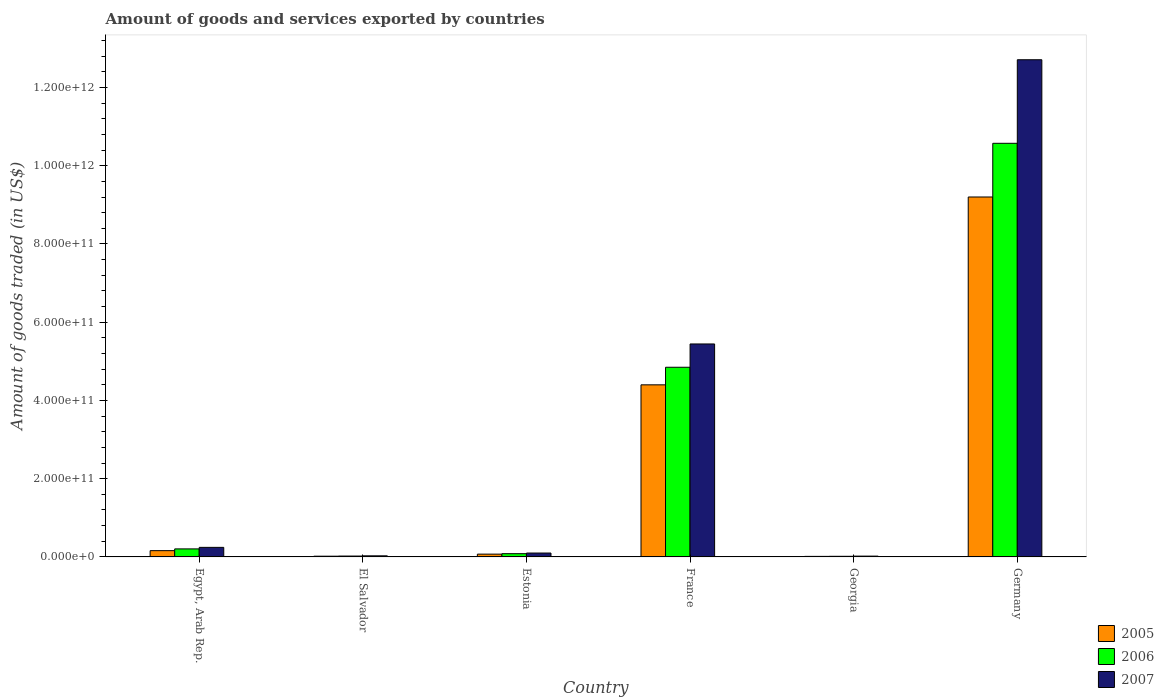How many groups of bars are there?
Your response must be concise. 6. Are the number of bars per tick equal to the number of legend labels?
Your response must be concise. Yes. How many bars are there on the 1st tick from the left?
Ensure brevity in your answer.  3. How many bars are there on the 2nd tick from the right?
Keep it short and to the point. 3. What is the label of the 2nd group of bars from the left?
Keep it short and to the point. El Salvador. What is the total amount of goods and services exported in 2005 in Georgia?
Your answer should be compact. 1.41e+09. Across all countries, what is the maximum total amount of goods and services exported in 2006?
Offer a terse response. 1.06e+12. Across all countries, what is the minimum total amount of goods and services exported in 2007?
Provide a short and direct response. 2.06e+09. In which country was the total amount of goods and services exported in 2005 minimum?
Keep it short and to the point. Georgia. What is the total total amount of goods and services exported in 2006 in the graph?
Offer a very short reply. 1.57e+12. What is the difference between the total amount of goods and services exported in 2005 in France and that in Germany?
Offer a very short reply. -4.80e+11. What is the difference between the total amount of goods and services exported in 2007 in France and the total amount of goods and services exported in 2006 in El Salvador?
Offer a very short reply. 5.42e+11. What is the average total amount of goods and services exported in 2006 per country?
Ensure brevity in your answer.  2.62e+11. What is the difference between the total amount of goods and services exported of/in 2006 and total amount of goods and services exported of/in 2007 in Georgia?
Ensure brevity in your answer.  -4.69e+08. In how many countries, is the total amount of goods and services exported in 2006 greater than 1200000000000 US$?
Your answer should be very brief. 0. What is the ratio of the total amount of goods and services exported in 2005 in El Salvador to that in Germany?
Your answer should be very brief. 0. What is the difference between the highest and the second highest total amount of goods and services exported in 2006?
Your response must be concise. 1.04e+12. What is the difference between the highest and the lowest total amount of goods and services exported in 2007?
Offer a very short reply. 1.27e+12. Is the sum of the total amount of goods and services exported in 2007 in El Salvador and Estonia greater than the maximum total amount of goods and services exported in 2005 across all countries?
Offer a very short reply. No. What does the 2nd bar from the right in Germany represents?
Give a very brief answer. 2006. Is it the case that in every country, the sum of the total amount of goods and services exported in 2007 and total amount of goods and services exported in 2005 is greater than the total amount of goods and services exported in 2006?
Your response must be concise. Yes. How many bars are there?
Ensure brevity in your answer.  18. Are all the bars in the graph horizontal?
Provide a short and direct response. No. What is the difference between two consecutive major ticks on the Y-axis?
Offer a very short reply. 2.00e+11. Does the graph contain grids?
Provide a succinct answer. No. What is the title of the graph?
Your answer should be very brief. Amount of goods and services exported by countries. Does "1989" appear as one of the legend labels in the graph?
Provide a succinct answer. No. What is the label or title of the X-axis?
Ensure brevity in your answer.  Country. What is the label or title of the Y-axis?
Keep it short and to the point. Amount of goods traded (in US$). What is the Amount of goods traded (in US$) of 2005 in Egypt, Arab Rep.?
Keep it short and to the point. 1.61e+1. What is the Amount of goods traded (in US$) in 2006 in Egypt, Arab Rep.?
Offer a very short reply. 2.05e+1. What is the Amount of goods traded (in US$) in 2007 in Egypt, Arab Rep.?
Make the answer very short. 2.45e+1. What is the Amount of goods traded (in US$) of 2005 in El Salvador?
Your answer should be very brief. 1.86e+09. What is the Amount of goods traded (in US$) in 2006 in El Salvador?
Your answer should be compact. 2.25e+09. What is the Amount of goods traded (in US$) in 2007 in El Salvador?
Offer a terse response. 2.79e+09. What is the Amount of goods traded (in US$) of 2005 in Estonia?
Offer a very short reply. 7.16e+09. What is the Amount of goods traded (in US$) of 2006 in Estonia?
Make the answer very short. 8.31e+09. What is the Amount of goods traded (in US$) in 2007 in Estonia?
Offer a terse response. 9.93e+09. What is the Amount of goods traded (in US$) of 2005 in France?
Provide a short and direct response. 4.40e+11. What is the Amount of goods traded (in US$) of 2006 in France?
Keep it short and to the point. 4.85e+11. What is the Amount of goods traded (in US$) of 2007 in France?
Your response must be concise. 5.44e+11. What is the Amount of goods traded (in US$) of 2005 in Georgia?
Your response must be concise. 1.41e+09. What is the Amount of goods traded (in US$) in 2006 in Georgia?
Offer a terse response. 1.59e+09. What is the Amount of goods traded (in US$) of 2007 in Georgia?
Your answer should be very brief. 2.06e+09. What is the Amount of goods traded (in US$) of 2005 in Germany?
Your answer should be very brief. 9.20e+11. What is the Amount of goods traded (in US$) of 2006 in Germany?
Provide a short and direct response. 1.06e+12. What is the Amount of goods traded (in US$) of 2007 in Germany?
Ensure brevity in your answer.  1.27e+12. Across all countries, what is the maximum Amount of goods traded (in US$) in 2005?
Offer a terse response. 9.20e+11. Across all countries, what is the maximum Amount of goods traded (in US$) of 2006?
Your answer should be very brief. 1.06e+12. Across all countries, what is the maximum Amount of goods traded (in US$) in 2007?
Provide a succinct answer. 1.27e+12. Across all countries, what is the minimum Amount of goods traded (in US$) in 2005?
Your response must be concise. 1.41e+09. Across all countries, what is the minimum Amount of goods traded (in US$) of 2006?
Offer a very short reply. 1.59e+09. Across all countries, what is the minimum Amount of goods traded (in US$) in 2007?
Your response must be concise. 2.06e+09. What is the total Amount of goods traded (in US$) in 2005 in the graph?
Your answer should be compact. 1.39e+12. What is the total Amount of goods traded (in US$) of 2006 in the graph?
Offer a terse response. 1.57e+12. What is the total Amount of goods traded (in US$) in 2007 in the graph?
Keep it short and to the point. 1.85e+12. What is the difference between the Amount of goods traded (in US$) of 2005 in Egypt, Arab Rep. and that in El Salvador?
Provide a short and direct response. 1.42e+1. What is the difference between the Amount of goods traded (in US$) in 2006 in Egypt, Arab Rep. and that in El Salvador?
Offer a terse response. 1.83e+1. What is the difference between the Amount of goods traded (in US$) of 2007 in Egypt, Arab Rep. and that in El Salvador?
Offer a terse response. 2.17e+1. What is the difference between the Amount of goods traded (in US$) of 2005 in Egypt, Arab Rep. and that in Estonia?
Give a very brief answer. 8.91e+09. What is the difference between the Amount of goods traded (in US$) of 2006 in Egypt, Arab Rep. and that in Estonia?
Give a very brief answer. 1.22e+1. What is the difference between the Amount of goods traded (in US$) of 2007 in Egypt, Arab Rep. and that in Estonia?
Your response must be concise. 1.45e+1. What is the difference between the Amount of goods traded (in US$) of 2005 in Egypt, Arab Rep. and that in France?
Your answer should be compact. -4.24e+11. What is the difference between the Amount of goods traded (in US$) in 2006 in Egypt, Arab Rep. and that in France?
Provide a short and direct response. -4.64e+11. What is the difference between the Amount of goods traded (in US$) in 2007 in Egypt, Arab Rep. and that in France?
Your answer should be compact. -5.20e+11. What is the difference between the Amount of goods traded (in US$) of 2005 in Egypt, Arab Rep. and that in Georgia?
Your answer should be very brief. 1.47e+1. What is the difference between the Amount of goods traded (in US$) of 2006 in Egypt, Arab Rep. and that in Georgia?
Your response must be concise. 1.90e+1. What is the difference between the Amount of goods traded (in US$) in 2007 in Egypt, Arab Rep. and that in Georgia?
Offer a terse response. 2.24e+1. What is the difference between the Amount of goods traded (in US$) in 2005 in Egypt, Arab Rep. and that in Germany?
Offer a terse response. -9.04e+11. What is the difference between the Amount of goods traded (in US$) in 2006 in Egypt, Arab Rep. and that in Germany?
Ensure brevity in your answer.  -1.04e+12. What is the difference between the Amount of goods traded (in US$) in 2007 in Egypt, Arab Rep. and that in Germany?
Your response must be concise. -1.25e+12. What is the difference between the Amount of goods traded (in US$) in 2005 in El Salvador and that in Estonia?
Provide a short and direct response. -5.30e+09. What is the difference between the Amount of goods traded (in US$) in 2006 in El Salvador and that in Estonia?
Provide a succinct answer. -6.05e+09. What is the difference between the Amount of goods traded (in US$) of 2007 in El Salvador and that in Estonia?
Your response must be concise. -7.13e+09. What is the difference between the Amount of goods traded (in US$) in 2005 in El Salvador and that in France?
Keep it short and to the point. -4.38e+11. What is the difference between the Amount of goods traded (in US$) in 2006 in El Salvador and that in France?
Give a very brief answer. -4.83e+11. What is the difference between the Amount of goods traded (in US$) of 2007 in El Salvador and that in France?
Offer a very short reply. -5.42e+11. What is the difference between the Amount of goods traded (in US$) of 2005 in El Salvador and that in Georgia?
Your response must be concise. 4.50e+08. What is the difference between the Amount of goods traded (in US$) in 2006 in El Salvador and that in Georgia?
Give a very brief answer. 6.68e+08. What is the difference between the Amount of goods traded (in US$) in 2007 in El Salvador and that in Georgia?
Provide a short and direct response. 7.38e+08. What is the difference between the Amount of goods traded (in US$) in 2005 in El Salvador and that in Germany?
Your answer should be compact. -9.18e+11. What is the difference between the Amount of goods traded (in US$) of 2006 in El Salvador and that in Germany?
Provide a succinct answer. -1.06e+12. What is the difference between the Amount of goods traded (in US$) of 2007 in El Salvador and that in Germany?
Make the answer very short. -1.27e+12. What is the difference between the Amount of goods traded (in US$) of 2005 in Estonia and that in France?
Your answer should be compact. -4.33e+11. What is the difference between the Amount of goods traded (in US$) of 2006 in Estonia and that in France?
Offer a very short reply. -4.77e+11. What is the difference between the Amount of goods traded (in US$) in 2007 in Estonia and that in France?
Offer a terse response. -5.34e+11. What is the difference between the Amount of goods traded (in US$) of 2005 in Estonia and that in Georgia?
Provide a succinct answer. 5.75e+09. What is the difference between the Amount of goods traded (in US$) of 2006 in Estonia and that in Georgia?
Your response must be concise. 6.72e+09. What is the difference between the Amount of goods traded (in US$) in 2007 in Estonia and that in Georgia?
Your response must be concise. 7.87e+09. What is the difference between the Amount of goods traded (in US$) in 2005 in Estonia and that in Germany?
Offer a terse response. -9.13e+11. What is the difference between the Amount of goods traded (in US$) of 2006 in Estonia and that in Germany?
Your answer should be very brief. -1.05e+12. What is the difference between the Amount of goods traded (in US$) of 2007 in Estonia and that in Germany?
Provide a succinct answer. -1.26e+12. What is the difference between the Amount of goods traded (in US$) of 2005 in France and that in Georgia?
Offer a terse response. 4.38e+11. What is the difference between the Amount of goods traded (in US$) of 2006 in France and that in Georgia?
Offer a very short reply. 4.83e+11. What is the difference between the Amount of goods traded (in US$) of 2007 in France and that in Georgia?
Offer a very short reply. 5.42e+11. What is the difference between the Amount of goods traded (in US$) of 2005 in France and that in Germany?
Your answer should be very brief. -4.80e+11. What is the difference between the Amount of goods traded (in US$) of 2006 in France and that in Germany?
Ensure brevity in your answer.  -5.72e+11. What is the difference between the Amount of goods traded (in US$) in 2007 in France and that in Germany?
Provide a succinct answer. -7.27e+11. What is the difference between the Amount of goods traded (in US$) of 2005 in Georgia and that in Germany?
Offer a very short reply. -9.19e+11. What is the difference between the Amount of goods traded (in US$) in 2006 in Georgia and that in Germany?
Make the answer very short. -1.06e+12. What is the difference between the Amount of goods traded (in US$) of 2007 in Georgia and that in Germany?
Keep it short and to the point. -1.27e+12. What is the difference between the Amount of goods traded (in US$) of 2005 in Egypt, Arab Rep. and the Amount of goods traded (in US$) of 2006 in El Salvador?
Provide a short and direct response. 1.38e+1. What is the difference between the Amount of goods traded (in US$) in 2005 in Egypt, Arab Rep. and the Amount of goods traded (in US$) in 2007 in El Salvador?
Your answer should be compact. 1.33e+1. What is the difference between the Amount of goods traded (in US$) of 2006 in Egypt, Arab Rep. and the Amount of goods traded (in US$) of 2007 in El Salvador?
Offer a very short reply. 1.78e+1. What is the difference between the Amount of goods traded (in US$) in 2005 in Egypt, Arab Rep. and the Amount of goods traded (in US$) in 2006 in Estonia?
Give a very brief answer. 7.76e+09. What is the difference between the Amount of goods traded (in US$) in 2005 in Egypt, Arab Rep. and the Amount of goods traded (in US$) in 2007 in Estonia?
Provide a short and direct response. 6.15e+09. What is the difference between the Amount of goods traded (in US$) of 2006 in Egypt, Arab Rep. and the Amount of goods traded (in US$) of 2007 in Estonia?
Your response must be concise. 1.06e+1. What is the difference between the Amount of goods traded (in US$) in 2005 in Egypt, Arab Rep. and the Amount of goods traded (in US$) in 2006 in France?
Your answer should be very brief. -4.69e+11. What is the difference between the Amount of goods traded (in US$) in 2005 in Egypt, Arab Rep. and the Amount of goods traded (in US$) in 2007 in France?
Keep it short and to the point. -5.28e+11. What is the difference between the Amount of goods traded (in US$) in 2006 in Egypt, Arab Rep. and the Amount of goods traded (in US$) in 2007 in France?
Provide a short and direct response. -5.24e+11. What is the difference between the Amount of goods traded (in US$) of 2005 in Egypt, Arab Rep. and the Amount of goods traded (in US$) of 2006 in Georgia?
Your answer should be compact. 1.45e+1. What is the difference between the Amount of goods traded (in US$) in 2005 in Egypt, Arab Rep. and the Amount of goods traded (in US$) in 2007 in Georgia?
Provide a short and direct response. 1.40e+1. What is the difference between the Amount of goods traded (in US$) of 2006 in Egypt, Arab Rep. and the Amount of goods traded (in US$) of 2007 in Georgia?
Make the answer very short. 1.85e+1. What is the difference between the Amount of goods traded (in US$) of 2005 in Egypt, Arab Rep. and the Amount of goods traded (in US$) of 2006 in Germany?
Provide a short and direct response. -1.04e+12. What is the difference between the Amount of goods traded (in US$) in 2005 in Egypt, Arab Rep. and the Amount of goods traded (in US$) in 2007 in Germany?
Your answer should be compact. -1.25e+12. What is the difference between the Amount of goods traded (in US$) of 2006 in Egypt, Arab Rep. and the Amount of goods traded (in US$) of 2007 in Germany?
Offer a terse response. -1.25e+12. What is the difference between the Amount of goods traded (in US$) of 2005 in El Salvador and the Amount of goods traded (in US$) of 2006 in Estonia?
Give a very brief answer. -6.44e+09. What is the difference between the Amount of goods traded (in US$) of 2005 in El Salvador and the Amount of goods traded (in US$) of 2007 in Estonia?
Keep it short and to the point. -8.06e+09. What is the difference between the Amount of goods traded (in US$) in 2006 in El Salvador and the Amount of goods traded (in US$) in 2007 in Estonia?
Your response must be concise. -7.67e+09. What is the difference between the Amount of goods traded (in US$) of 2005 in El Salvador and the Amount of goods traded (in US$) of 2006 in France?
Give a very brief answer. -4.83e+11. What is the difference between the Amount of goods traded (in US$) of 2005 in El Salvador and the Amount of goods traded (in US$) of 2007 in France?
Give a very brief answer. -5.43e+11. What is the difference between the Amount of goods traded (in US$) in 2006 in El Salvador and the Amount of goods traded (in US$) in 2007 in France?
Keep it short and to the point. -5.42e+11. What is the difference between the Amount of goods traded (in US$) in 2005 in El Salvador and the Amount of goods traded (in US$) in 2006 in Georgia?
Provide a short and direct response. 2.78e+08. What is the difference between the Amount of goods traded (in US$) of 2005 in El Salvador and the Amount of goods traded (in US$) of 2007 in Georgia?
Offer a very short reply. -1.92e+08. What is the difference between the Amount of goods traded (in US$) of 2006 in El Salvador and the Amount of goods traded (in US$) of 2007 in Georgia?
Offer a very short reply. 1.99e+08. What is the difference between the Amount of goods traded (in US$) of 2005 in El Salvador and the Amount of goods traded (in US$) of 2006 in Germany?
Provide a short and direct response. -1.06e+12. What is the difference between the Amount of goods traded (in US$) in 2005 in El Salvador and the Amount of goods traded (in US$) in 2007 in Germany?
Offer a very short reply. -1.27e+12. What is the difference between the Amount of goods traded (in US$) in 2006 in El Salvador and the Amount of goods traded (in US$) in 2007 in Germany?
Make the answer very short. -1.27e+12. What is the difference between the Amount of goods traded (in US$) of 2005 in Estonia and the Amount of goods traded (in US$) of 2006 in France?
Your response must be concise. -4.78e+11. What is the difference between the Amount of goods traded (in US$) of 2005 in Estonia and the Amount of goods traded (in US$) of 2007 in France?
Make the answer very short. -5.37e+11. What is the difference between the Amount of goods traded (in US$) in 2006 in Estonia and the Amount of goods traded (in US$) in 2007 in France?
Your answer should be very brief. -5.36e+11. What is the difference between the Amount of goods traded (in US$) in 2005 in Estonia and the Amount of goods traded (in US$) in 2006 in Georgia?
Your answer should be compact. 5.57e+09. What is the difference between the Amount of goods traded (in US$) in 2005 in Estonia and the Amount of goods traded (in US$) in 2007 in Georgia?
Offer a terse response. 5.10e+09. What is the difference between the Amount of goods traded (in US$) of 2006 in Estonia and the Amount of goods traded (in US$) of 2007 in Georgia?
Provide a succinct answer. 6.25e+09. What is the difference between the Amount of goods traded (in US$) in 2005 in Estonia and the Amount of goods traded (in US$) in 2006 in Germany?
Ensure brevity in your answer.  -1.05e+12. What is the difference between the Amount of goods traded (in US$) in 2005 in Estonia and the Amount of goods traded (in US$) in 2007 in Germany?
Offer a terse response. -1.26e+12. What is the difference between the Amount of goods traded (in US$) in 2006 in Estonia and the Amount of goods traded (in US$) in 2007 in Germany?
Provide a succinct answer. -1.26e+12. What is the difference between the Amount of goods traded (in US$) of 2005 in France and the Amount of goods traded (in US$) of 2006 in Georgia?
Provide a short and direct response. 4.38e+11. What is the difference between the Amount of goods traded (in US$) in 2005 in France and the Amount of goods traded (in US$) in 2007 in Georgia?
Ensure brevity in your answer.  4.38e+11. What is the difference between the Amount of goods traded (in US$) in 2006 in France and the Amount of goods traded (in US$) in 2007 in Georgia?
Offer a very short reply. 4.83e+11. What is the difference between the Amount of goods traded (in US$) in 2005 in France and the Amount of goods traded (in US$) in 2006 in Germany?
Ensure brevity in your answer.  -6.17e+11. What is the difference between the Amount of goods traded (in US$) of 2005 in France and the Amount of goods traded (in US$) of 2007 in Germany?
Provide a short and direct response. -8.31e+11. What is the difference between the Amount of goods traded (in US$) in 2006 in France and the Amount of goods traded (in US$) in 2007 in Germany?
Your answer should be compact. -7.86e+11. What is the difference between the Amount of goods traded (in US$) of 2005 in Georgia and the Amount of goods traded (in US$) of 2006 in Germany?
Your answer should be very brief. -1.06e+12. What is the difference between the Amount of goods traded (in US$) of 2005 in Georgia and the Amount of goods traded (in US$) of 2007 in Germany?
Your answer should be very brief. -1.27e+12. What is the difference between the Amount of goods traded (in US$) in 2006 in Georgia and the Amount of goods traded (in US$) in 2007 in Germany?
Ensure brevity in your answer.  -1.27e+12. What is the average Amount of goods traded (in US$) of 2005 per country?
Offer a very short reply. 2.31e+11. What is the average Amount of goods traded (in US$) of 2006 per country?
Provide a succinct answer. 2.62e+11. What is the average Amount of goods traded (in US$) in 2007 per country?
Ensure brevity in your answer.  3.09e+11. What is the difference between the Amount of goods traded (in US$) in 2005 and Amount of goods traded (in US$) in 2006 in Egypt, Arab Rep.?
Offer a very short reply. -4.47e+09. What is the difference between the Amount of goods traded (in US$) of 2005 and Amount of goods traded (in US$) of 2007 in Egypt, Arab Rep.?
Make the answer very short. -8.38e+09. What is the difference between the Amount of goods traded (in US$) of 2006 and Amount of goods traded (in US$) of 2007 in Egypt, Arab Rep.?
Offer a terse response. -3.91e+09. What is the difference between the Amount of goods traded (in US$) in 2005 and Amount of goods traded (in US$) in 2006 in El Salvador?
Your answer should be compact. -3.91e+08. What is the difference between the Amount of goods traded (in US$) of 2005 and Amount of goods traded (in US$) of 2007 in El Salvador?
Offer a terse response. -9.30e+08. What is the difference between the Amount of goods traded (in US$) of 2006 and Amount of goods traded (in US$) of 2007 in El Salvador?
Offer a very short reply. -5.39e+08. What is the difference between the Amount of goods traded (in US$) in 2005 and Amount of goods traded (in US$) in 2006 in Estonia?
Ensure brevity in your answer.  -1.15e+09. What is the difference between the Amount of goods traded (in US$) in 2005 and Amount of goods traded (in US$) in 2007 in Estonia?
Keep it short and to the point. -2.77e+09. What is the difference between the Amount of goods traded (in US$) in 2006 and Amount of goods traded (in US$) in 2007 in Estonia?
Give a very brief answer. -1.62e+09. What is the difference between the Amount of goods traded (in US$) in 2005 and Amount of goods traded (in US$) in 2006 in France?
Your response must be concise. -4.50e+1. What is the difference between the Amount of goods traded (in US$) of 2005 and Amount of goods traded (in US$) of 2007 in France?
Ensure brevity in your answer.  -1.05e+11. What is the difference between the Amount of goods traded (in US$) of 2006 and Amount of goods traded (in US$) of 2007 in France?
Make the answer very short. -5.96e+1. What is the difference between the Amount of goods traded (in US$) in 2005 and Amount of goods traded (in US$) in 2006 in Georgia?
Provide a short and direct response. -1.73e+08. What is the difference between the Amount of goods traded (in US$) of 2005 and Amount of goods traded (in US$) of 2007 in Georgia?
Your answer should be compact. -6.42e+08. What is the difference between the Amount of goods traded (in US$) of 2006 and Amount of goods traded (in US$) of 2007 in Georgia?
Offer a terse response. -4.69e+08. What is the difference between the Amount of goods traded (in US$) in 2005 and Amount of goods traded (in US$) in 2006 in Germany?
Your answer should be very brief. -1.37e+11. What is the difference between the Amount of goods traded (in US$) in 2005 and Amount of goods traded (in US$) in 2007 in Germany?
Provide a short and direct response. -3.51e+11. What is the difference between the Amount of goods traded (in US$) of 2006 and Amount of goods traded (in US$) of 2007 in Germany?
Make the answer very short. -2.14e+11. What is the ratio of the Amount of goods traded (in US$) of 2005 in Egypt, Arab Rep. to that in El Salvador?
Provide a succinct answer. 8.62. What is the ratio of the Amount of goods traded (in US$) in 2006 in Egypt, Arab Rep. to that in El Salvador?
Give a very brief answer. 9.11. What is the ratio of the Amount of goods traded (in US$) of 2007 in Egypt, Arab Rep. to that in El Salvador?
Make the answer very short. 8.75. What is the ratio of the Amount of goods traded (in US$) of 2005 in Egypt, Arab Rep. to that in Estonia?
Provide a succinct answer. 2.24. What is the ratio of the Amount of goods traded (in US$) in 2006 in Egypt, Arab Rep. to that in Estonia?
Provide a succinct answer. 2.47. What is the ratio of the Amount of goods traded (in US$) of 2007 in Egypt, Arab Rep. to that in Estonia?
Provide a short and direct response. 2.46. What is the ratio of the Amount of goods traded (in US$) of 2005 in Egypt, Arab Rep. to that in France?
Give a very brief answer. 0.04. What is the ratio of the Amount of goods traded (in US$) of 2006 in Egypt, Arab Rep. to that in France?
Ensure brevity in your answer.  0.04. What is the ratio of the Amount of goods traded (in US$) in 2007 in Egypt, Arab Rep. to that in France?
Your answer should be very brief. 0.04. What is the ratio of the Amount of goods traded (in US$) of 2005 in Egypt, Arab Rep. to that in Georgia?
Your answer should be very brief. 11.37. What is the ratio of the Amount of goods traded (in US$) in 2006 in Egypt, Arab Rep. to that in Georgia?
Offer a terse response. 12.95. What is the ratio of the Amount of goods traded (in US$) in 2007 in Egypt, Arab Rep. to that in Georgia?
Ensure brevity in your answer.  11.9. What is the ratio of the Amount of goods traded (in US$) in 2005 in Egypt, Arab Rep. to that in Germany?
Offer a terse response. 0.02. What is the ratio of the Amount of goods traded (in US$) of 2006 in Egypt, Arab Rep. to that in Germany?
Offer a very short reply. 0.02. What is the ratio of the Amount of goods traded (in US$) in 2007 in Egypt, Arab Rep. to that in Germany?
Your answer should be compact. 0.02. What is the ratio of the Amount of goods traded (in US$) of 2005 in El Salvador to that in Estonia?
Your answer should be very brief. 0.26. What is the ratio of the Amount of goods traded (in US$) in 2006 in El Salvador to that in Estonia?
Ensure brevity in your answer.  0.27. What is the ratio of the Amount of goods traded (in US$) in 2007 in El Salvador to that in Estonia?
Offer a very short reply. 0.28. What is the ratio of the Amount of goods traded (in US$) of 2005 in El Salvador to that in France?
Your answer should be compact. 0. What is the ratio of the Amount of goods traded (in US$) in 2006 in El Salvador to that in France?
Keep it short and to the point. 0. What is the ratio of the Amount of goods traded (in US$) in 2007 in El Salvador to that in France?
Keep it short and to the point. 0.01. What is the ratio of the Amount of goods traded (in US$) of 2005 in El Salvador to that in Georgia?
Offer a very short reply. 1.32. What is the ratio of the Amount of goods traded (in US$) in 2006 in El Salvador to that in Georgia?
Make the answer very short. 1.42. What is the ratio of the Amount of goods traded (in US$) in 2007 in El Salvador to that in Georgia?
Offer a very short reply. 1.36. What is the ratio of the Amount of goods traded (in US$) in 2005 in El Salvador to that in Germany?
Your answer should be compact. 0. What is the ratio of the Amount of goods traded (in US$) in 2006 in El Salvador to that in Germany?
Keep it short and to the point. 0. What is the ratio of the Amount of goods traded (in US$) of 2007 in El Salvador to that in Germany?
Provide a succinct answer. 0. What is the ratio of the Amount of goods traded (in US$) in 2005 in Estonia to that in France?
Provide a short and direct response. 0.02. What is the ratio of the Amount of goods traded (in US$) in 2006 in Estonia to that in France?
Make the answer very short. 0.02. What is the ratio of the Amount of goods traded (in US$) in 2007 in Estonia to that in France?
Your answer should be compact. 0.02. What is the ratio of the Amount of goods traded (in US$) in 2005 in Estonia to that in Georgia?
Make the answer very short. 5.06. What is the ratio of the Amount of goods traded (in US$) of 2006 in Estonia to that in Georgia?
Provide a succinct answer. 5.24. What is the ratio of the Amount of goods traded (in US$) of 2007 in Estonia to that in Georgia?
Provide a short and direct response. 4.83. What is the ratio of the Amount of goods traded (in US$) of 2005 in Estonia to that in Germany?
Your answer should be compact. 0.01. What is the ratio of the Amount of goods traded (in US$) in 2006 in Estonia to that in Germany?
Offer a terse response. 0.01. What is the ratio of the Amount of goods traded (in US$) in 2007 in Estonia to that in Germany?
Provide a succinct answer. 0.01. What is the ratio of the Amount of goods traded (in US$) of 2005 in France to that in Georgia?
Offer a very short reply. 311.12. What is the ratio of the Amount of goods traded (in US$) in 2006 in France to that in Georgia?
Keep it short and to the point. 305.63. What is the ratio of the Amount of goods traded (in US$) in 2007 in France to that in Georgia?
Keep it short and to the point. 264.84. What is the ratio of the Amount of goods traded (in US$) in 2005 in France to that in Germany?
Provide a short and direct response. 0.48. What is the ratio of the Amount of goods traded (in US$) in 2006 in France to that in Germany?
Your answer should be compact. 0.46. What is the ratio of the Amount of goods traded (in US$) in 2007 in France to that in Germany?
Ensure brevity in your answer.  0.43. What is the ratio of the Amount of goods traded (in US$) of 2005 in Georgia to that in Germany?
Your answer should be compact. 0. What is the ratio of the Amount of goods traded (in US$) in 2006 in Georgia to that in Germany?
Offer a very short reply. 0. What is the ratio of the Amount of goods traded (in US$) in 2007 in Georgia to that in Germany?
Give a very brief answer. 0. What is the difference between the highest and the second highest Amount of goods traded (in US$) of 2005?
Make the answer very short. 4.80e+11. What is the difference between the highest and the second highest Amount of goods traded (in US$) in 2006?
Provide a short and direct response. 5.72e+11. What is the difference between the highest and the second highest Amount of goods traded (in US$) of 2007?
Your answer should be compact. 7.27e+11. What is the difference between the highest and the lowest Amount of goods traded (in US$) of 2005?
Give a very brief answer. 9.19e+11. What is the difference between the highest and the lowest Amount of goods traded (in US$) of 2006?
Offer a terse response. 1.06e+12. What is the difference between the highest and the lowest Amount of goods traded (in US$) of 2007?
Your answer should be very brief. 1.27e+12. 